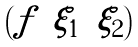Convert formula to latex. <formula><loc_0><loc_0><loc_500><loc_500>\begin{pmatrix} f & \xi _ { 1 } & \xi _ { 2 } \end{pmatrix}</formula> 